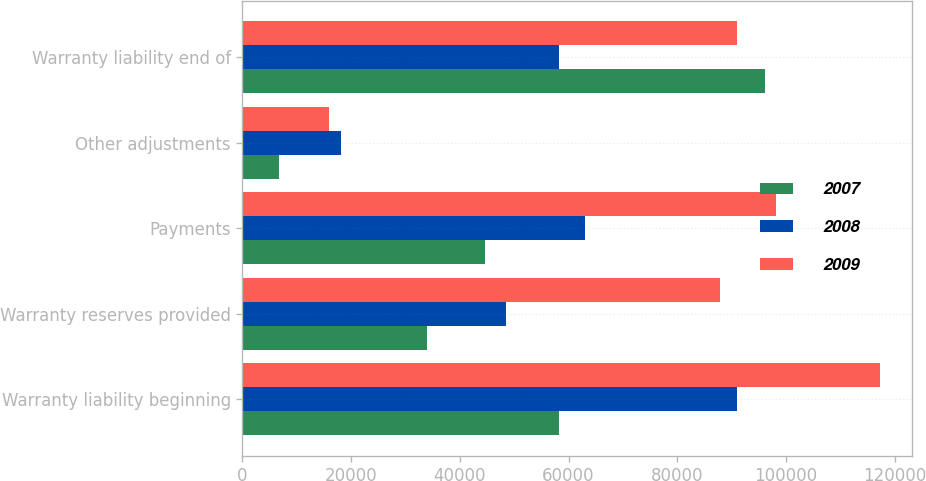<chart> <loc_0><loc_0><loc_500><loc_500><stacked_bar_chart><ecel><fcel>Warranty liability beginning<fcel>Warranty reserves provided<fcel>Payments<fcel>Other adjustments<fcel>Warranty liability end of<nl><fcel>2007<fcel>58178<fcel>34019<fcel>44600<fcel>6779<fcel>96110<nl><fcel>2008<fcel>90917<fcel>48515<fcel>63073<fcel>18181<fcel>58178<nl><fcel>2009<fcel>117259<fcel>87805<fcel>98235<fcel>15912<fcel>90917<nl></chart> 